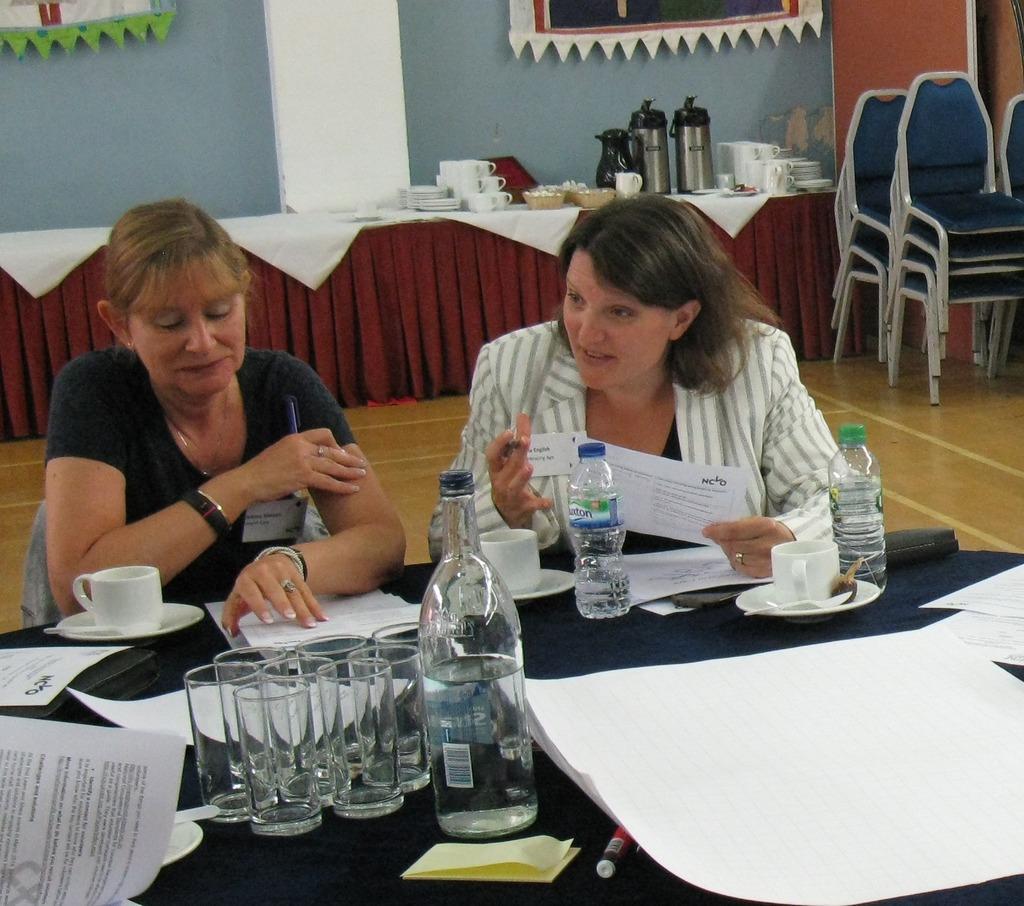Please provide a concise description of this image. This 2 persons are sitting on a chair. In-front of this 2 person there is a table, on a table there are papers, cup, bottles and glasses. Far there are chairs. Beside this chair there is a table, on a table there is a jar and plates and bowls. Banners are attached to the wall. 